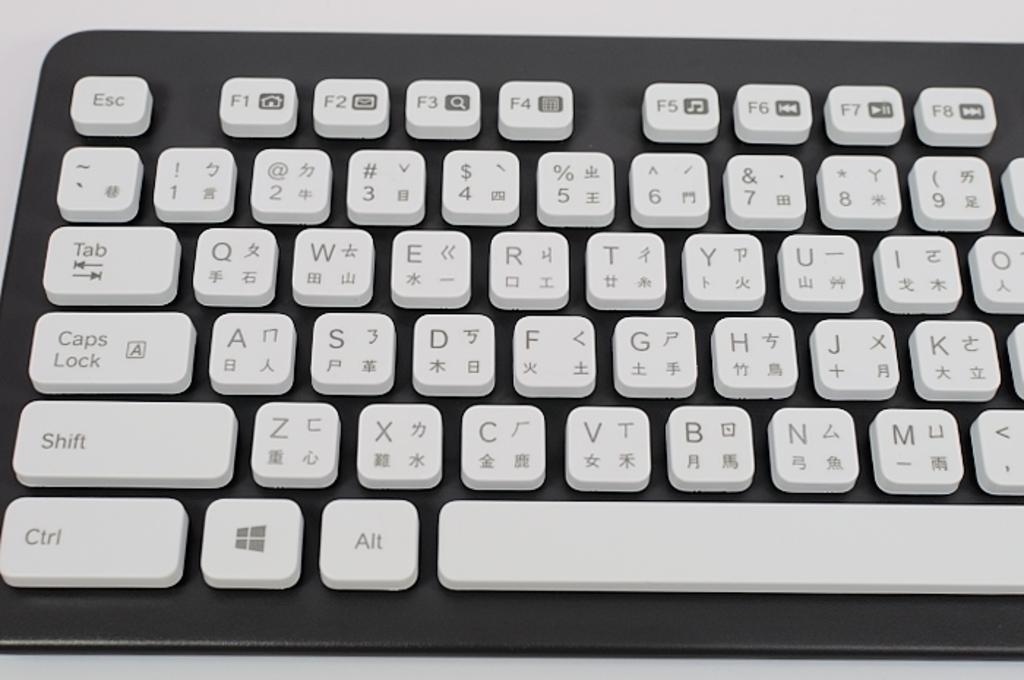What is the function of the key on the top left?
Provide a succinct answer. Esc. What key is on the bottom left?
Offer a very short reply. Ctrl. 